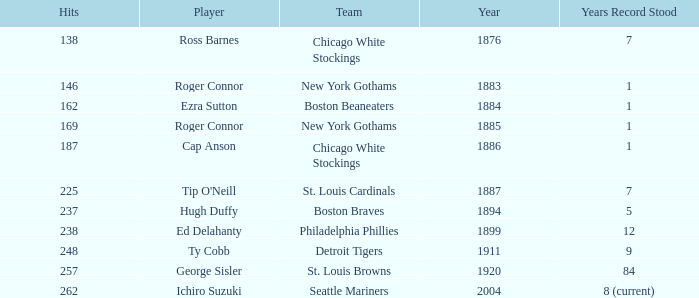Name the least hits for year less than 1920 and player of ed delahanty 238.0. 